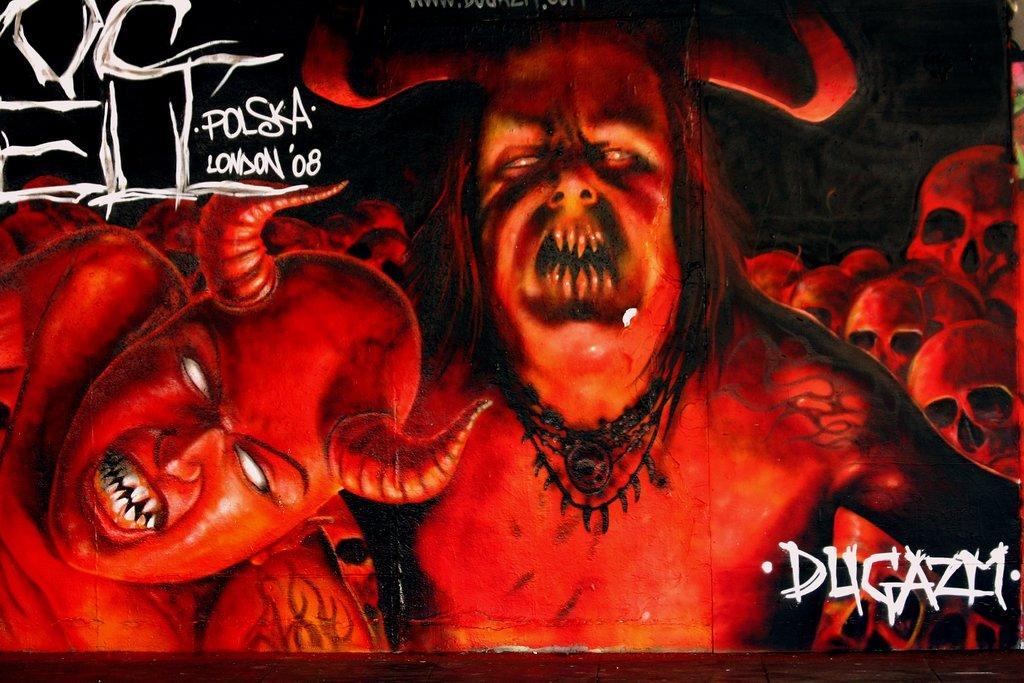What is the main subject of the image? The main subject of the image is a poster. What type of images are featured on the poster? The poster contains images of monsters. Is there any text present on the image? Yes, there is text written on the image. What can be seen in the background of the poster? There are skulls visible in the background of the image. What type of cracker is being used to build a snowman in the image? There is no cracker or snowman present in the image; it features a poster with images of monsters and text. 